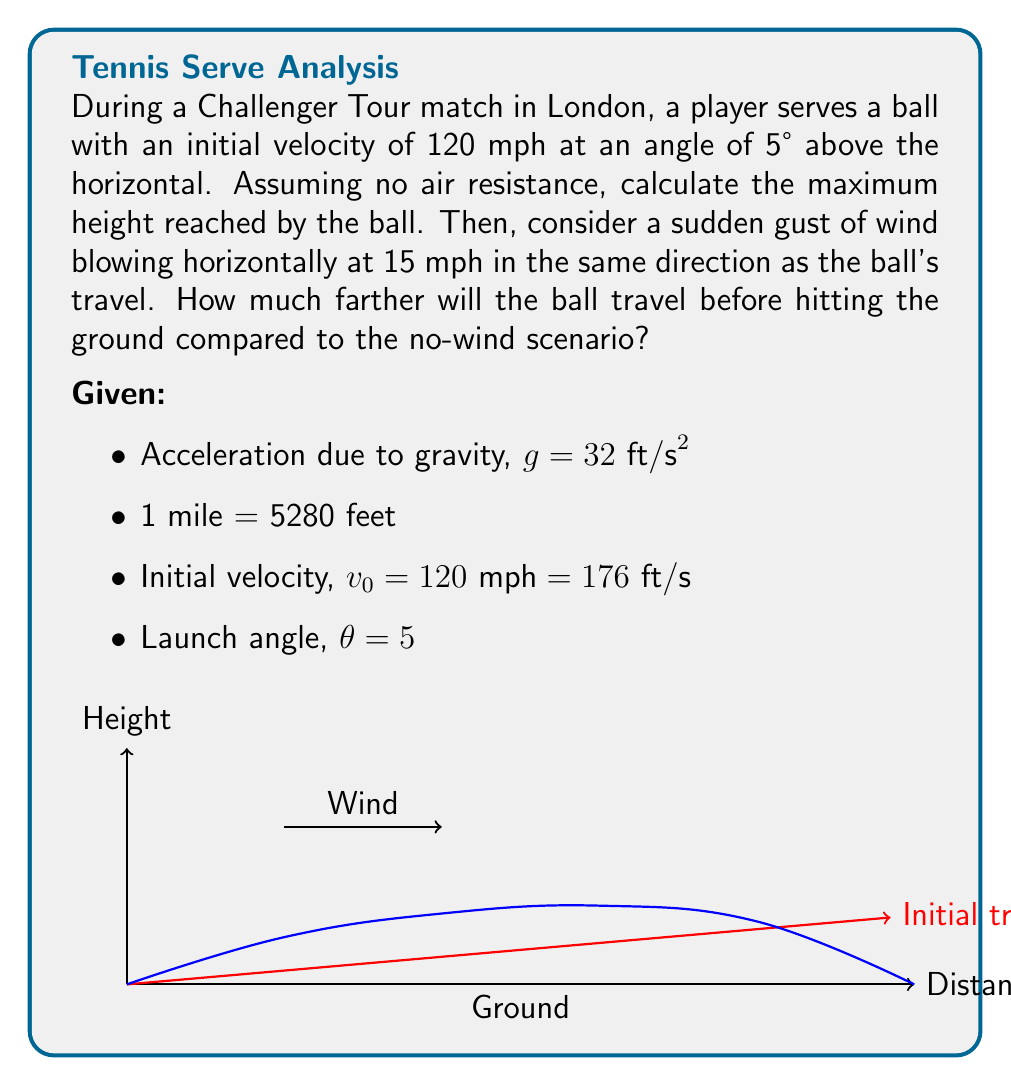Provide a solution to this math problem. Let's approach this problem step-by-step:

1) First, let's calculate the maximum height reached by the ball without wind:

   The vertical component of the initial velocity is:
   $$v_{0y} = v_0 \sin(\theta) = 176 \cdot \sin(5°) = 15.35 \text{ ft/s}$$

   The time to reach maximum height is given by:
   $$t_{max} = \frac{v_{0y}}{g} = \frac{15.35}{32} = 0.48 \text{ s}$$

   The maximum height is:
   $$h_{max} = v_{0y}t_{max} - \frac{1}{2}gt_{max}^2 = 15.35 \cdot 0.48 - \frac{1}{2} \cdot 32 \cdot 0.48^2 = 3.68 \text{ ft}$$

2) Now, let's calculate the total time of flight and range without wind:

   Total time of flight:
   $$t_{total} = \frac{2v_{0y}}{g} = \frac{2 \cdot 15.35}{32} = 0.96 \text{ s}$$

   The horizontal component of velocity:
   $$v_{0x} = v_0 \cos(\theta) = 176 \cdot \cos(5°) = 175.33 \text{ ft/s}$$

   Range without wind:
   $$R_{no wind} = v_{0x} \cdot t_{total} = 175.33 \cdot 0.96 = 168.32 \text{ ft}$$

3) With wind, the horizontal velocity becomes:
   $$v_x = v_{0x} + v_{wind} = 175.33 + 22 = 197.33 \text{ ft/s}$$
   (Note: We converted 15 mph to 22 ft/s)

   Range with wind:
   $$R_{wind} = v_x \cdot t_{total} = 197.33 \cdot 0.96 = 189.44 \text{ ft}$$

4) The difference in range:
   $$\Delta R = R_{wind} - R_{no wind} = 189.44 - 168.32 = 21.12 \text{ ft}$$
Answer: $3.68 \text{ ft}$; $21.12 \text{ ft}$ 